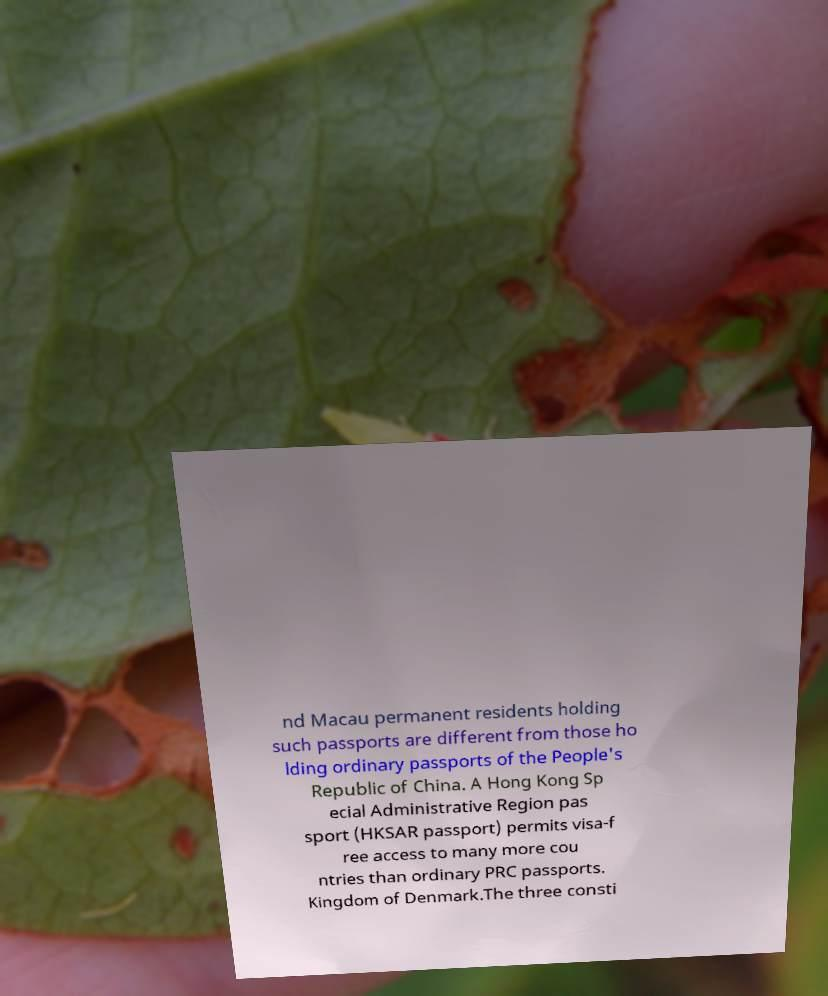There's text embedded in this image that I need extracted. Can you transcribe it verbatim? nd Macau permanent residents holding such passports are different from those ho lding ordinary passports of the People's Republic of China. A Hong Kong Sp ecial Administrative Region pas sport (HKSAR passport) permits visa-f ree access to many more cou ntries than ordinary PRC passports. Kingdom of Denmark.The three consti 